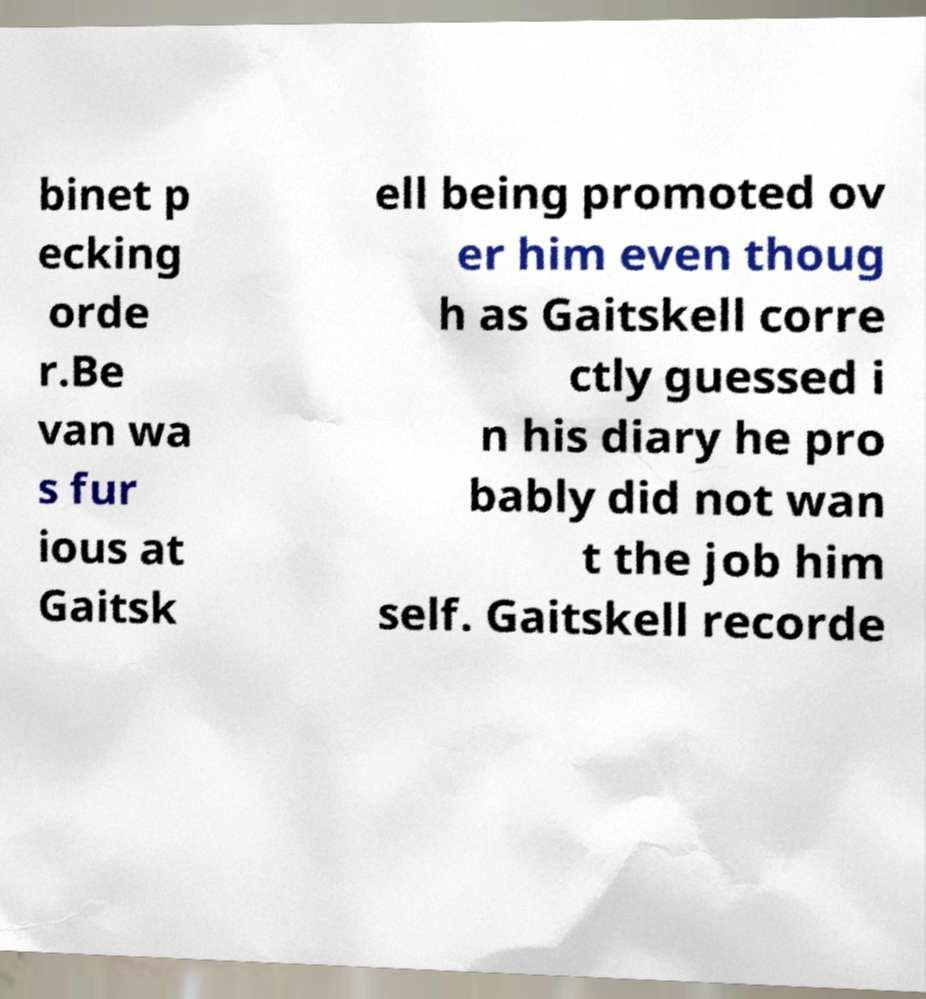For documentation purposes, I need the text within this image transcribed. Could you provide that? binet p ecking orde r.Be van wa s fur ious at Gaitsk ell being promoted ov er him even thoug h as Gaitskell corre ctly guessed i n his diary he pro bably did not wan t the job him self. Gaitskell recorde 